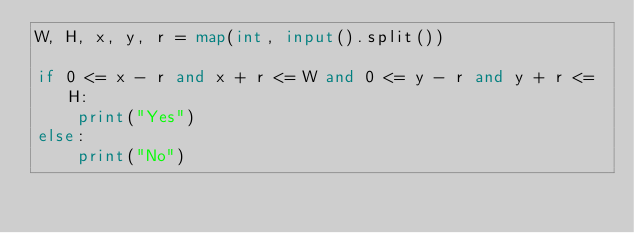<code> <loc_0><loc_0><loc_500><loc_500><_Python_>W, H, x, y, r = map(int, input().split())

if 0 <= x - r and x + r <= W and 0 <= y - r and y + r <= H:
    print("Yes")
else:
    print("No")

</code> 